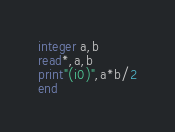Convert code to text. <code><loc_0><loc_0><loc_500><loc_500><_FORTRAN_>integer a,b
read*,a,b
print"(i0)",a*b/2
end</code> 